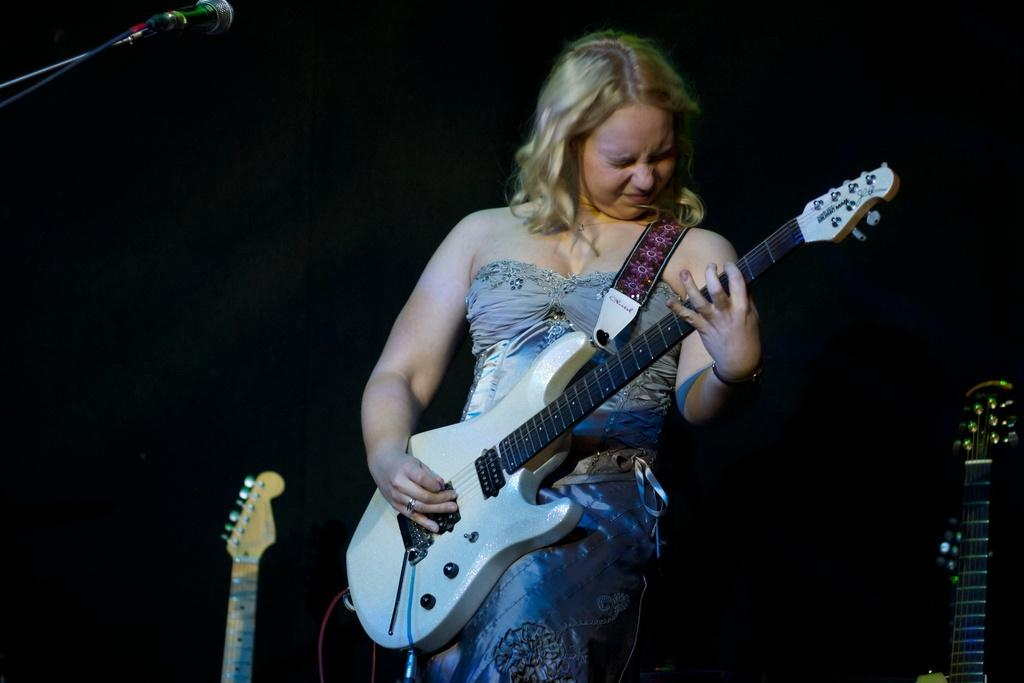Who is present in the image? There is a woman in the image. What is the woman doing in the image? The woman is standing in the image. What object is the woman holding in the image? The woman is holding a guitar in the image. Where are the guitars located in the image? There are guitars on both the right and left sides of the image. What can be seen in the top left corner of the image? There is a microphone in the top left corner of the image. What type of creature is playing the guitar in the image? There is no creature present in the image; it features a woman holding a guitar. Can you tell me how many ovens are visible in the image? There are no ovens present in the image. 